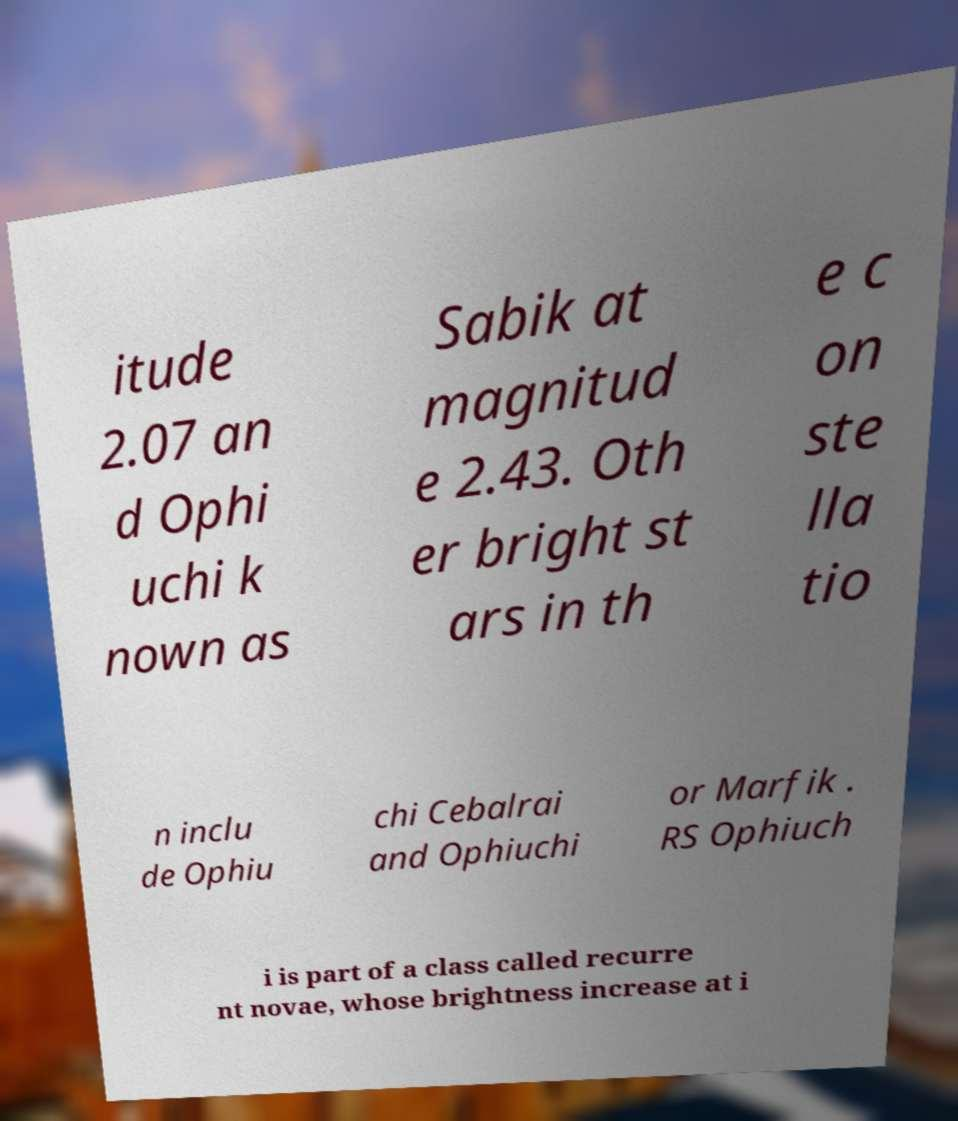Can you read and provide the text displayed in the image?This photo seems to have some interesting text. Can you extract and type it out for me? itude 2.07 an d Ophi uchi k nown as Sabik at magnitud e 2.43. Oth er bright st ars in th e c on ste lla tio n inclu de Ophiu chi Cebalrai and Ophiuchi or Marfik . RS Ophiuch i is part of a class called recurre nt novae, whose brightness increase at i 